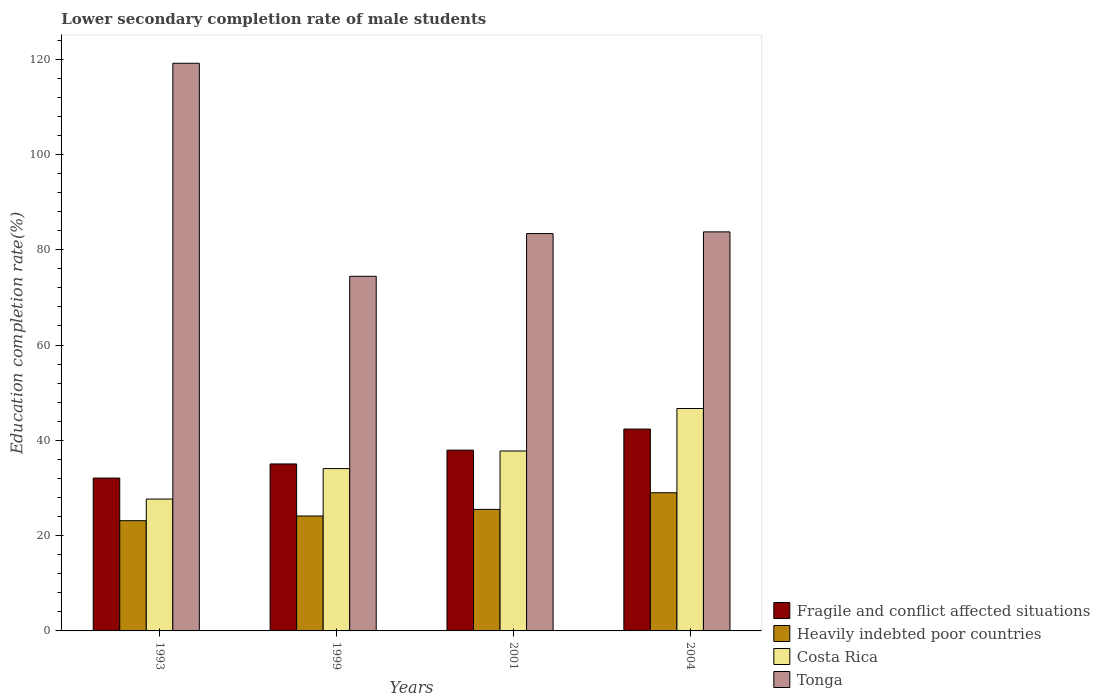How many groups of bars are there?
Provide a succinct answer. 4. Are the number of bars per tick equal to the number of legend labels?
Give a very brief answer. Yes. How many bars are there on the 2nd tick from the left?
Provide a short and direct response. 4. In how many cases, is the number of bars for a given year not equal to the number of legend labels?
Your answer should be compact. 0. What is the lower secondary completion rate of male students in Heavily indebted poor countries in 1993?
Make the answer very short. 23.13. Across all years, what is the maximum lower secondary completion rate of male students in Fragile and conflict affected situations?
Offer a very short reply. 42.36. Across all years, what is the minimum lower secondary completion rate of male students in Fragile and conflict affected situations?
Provide a short and direct response. 32.08. In which year was the lower secondary completion rate of male students in Fragile and conflict affected situations minimum?
Your answer should be very brief. 1993. What is the total lower secondary completion rate of male students in Fragile and conflict affected situations in the graph?
Offer a terse response. 147.43. What is the difference between the lower secondary completion rate of male students in Fragile and conflict affected situations in 1999 and that in 2004?
Make the answer very short. -7.32. What is the difference between the lower secondary completion rate of male students in Tonga in 1999 and the lower secondary completion rate of male students in Fragile and conflict affected situations in 2004?
Offer a very short reply. 32.06. What is the average lower secondary completion rate of male students in Fragile and conflict affected situations per year?
Your answer should be compact. 36.86. In the year 2001, what is the difference between the lower secondary completion rate of male students in Fragile and conflict affected situations and lower secondary completion rate of male students in Heavily indebted poor countries?
Make the answer very short. 12.43. In how many years, is the lower secondary completion rate of male students in Costa Rica greater than 4 %?
Give a very brief answer. 4. What is the ratio of the lower secondary completion rate of male students in Tonga in 1999 to that in 2004?
Ensure brevity in your answer.  0.89. Is the lower secondary completion rate of male students in Tonga in 1993 less than that in 2004?
Offer a terse response. No. Is the difference between the lower secondary completion rate of male students in Fragile and conflict affected situations in 1999 and 2001 greater than the difference between the lower secondary completion rate of male students in Heavily indebted poor countries in 1999 and 2001?
Give a very brief answer. No. What is the difference between the highest and the second highest lower secondary completion rate of male students in Heavily indebted poor countries?
Give a very brief answer. 3.49. What is the difference between the highest and the lowest lower secondary completion rate of male students in Costa Rica?
Keep it short and to the point. 19. Is the sum of the lower secondary completion rate of male students in Tonga in 1999 and 2004 greater than the maximum lower secondary completion rate of male students in Fragile and conflict affected situations across all years?
Give a very brief answer. Yes. What does the 1st bar from the left in 1993 represents?
Ensure brevity in your answer.  Fragile and conflict affected situations. Is it the case that in every year, the sum of the lower secondary completion rate of male students in Tonga and lower secondary completion rate of male students in Costa Rica is greater than the lower secondary completion rate of male students in Fragile and conflict affected situations?
Offer a terse response. Yes. How many bars are there?
Provide a succinct answer. 16. How many years are there in the graph?
Your answer should be compact. 4. Does the graph contain grids?
Offer a very short reply. No. Where does the legend appear in the graph?
Ensure brevity in your answer.  Bottom right. How many legend labels are there?
Make the answer very short. 4. What is the title of the graph?
Your answer should be compact. Lower secondary completion rate of male students. Does "Portugal" appear as one of the legend labels in the graph?
Your answer should be very brief. No. What is the label or title of the Y-axis?
Provide a succinct answer. Education completion rate(%). What is the Education completion rate(%) of Fragile and conflict affected situations in 1993?
Ensure brevity in your answer.  32.08. What is the Education completion rate(%) in Heavily indebted poor countries in 1993?
Provide a short and direct response. 23.13. What is the Education completion rate(%) of Costa Rica in 1993?
Ensure brevity in your answer.  27.67. What is the Education completion rate(%) of Tonga in 1993?
Make the answer very short. 119.14. What is the Education completion rate(%) in Fragile and conflict affected situations in 1999?
Provide a succinct answer. 35.04. What is the Education completion rate(%) of Heavily indebted poor countries in 1999?
Give a very brief answer. 24.12. What is the Education completion rate(%) in Costa Rica in 1999?
Make the answer very short. 34.07. What is the Education completion rate(%) in Tonga in 1999?
Your answer should be compact. 74.42. What is the Education completion rate(%) of Fragile and conflict affected situations in 2001?
Give a very brief answer. 37.94. What is the Education completion rate(%) in Heavily indebted poor countries in 2001?
Give a very brief answer. 25.51. What is the Education completion rate(%) in Costa Rica in 2001?
Make the answer very short. 37.76. What is the Education completion rate(%) of Tonga in 2001?
Ensure brevity in your answer.  83.39. What is the Education completion rate(%) of Fragile and conflict affected situations in 2004?
Your response must be concise. 42.36. What is the Education completion rate(%) in Heavily indebted poor countries in 2004?
Your answer should be very brief. 29. What is the Education completion rate(%) in Costa Rica in 2004?
Provide a succinct answer. 46.68. What is the Education completion rate(%) of Tonga in 2004?
Your answer should be compact. 83.75. Across all years, what is the maximum Education completion rate(%) of Fragile and conflict affected situations?
Give a very brief answer. 42.36. Across all years, what is the maximum Education completion rate(%) in Heavily indebted poor countries?
Offer a terse response. 29. Across all years, what is the maximum Education completion rate(%) of Costa Rica?
Your response must be concise. 46.68. Across all years, what is the maximum Education completion rate(%) of Tonga?
Give a very brief answer. 119.14. Across all years, what is the minimum Education completion rate(%) of Fragile and conflict affected situations?
Your response must be concise. 32.08. Across all years, what is the minimum Education completion rate(%) in Heavily indebted poor countries?
Provide a succinct answer. 23.13. Across all years, what is the minimum Education completion rate(%) of Costa Rica?
Make the answer very short. 27.67. Across all years, what is the minimum Education completion rate(%) of Tonga?
Offer a terse response. 74.42. What is the total Education completion rate(%) in Fragile and conflict affected situations in the graph?
Provide a succinct answer. 147.43. What is the total Education completion rate(%) of Heavily indebted poor countries in the graph?
Offer a terse response. 101.77. What is the total Education completion rate(%) of Costa Rica in the graph?
Provide a short and direct response. 146.18. What is the total Education completion rate(%) in Tonga in the graph?
Your answer should be compact. 360.69. What is the difference between the Education completion rate(%) of Fragile and conflict affected situations in 1993 and that in 1999?
Your answer should be compact. -2.96. What is the difference between the Education completion rate(%) in Heavily indebted poor countries in 1993 and that in 1999?
Your answer should be very brief. -0.99. What is the difference between the Education completion rate(%) of Costa Rica in 1993 and that in 1999?
Give a very brief answer. -6.4. What is the difference between the Education completion rate(%) in Tonga in 1993 and that in 1999?
Keep it short and to the point. 44.71. What is the difference between the Education completion rate(%) in Fragile and conflict affected situations in 1993 and that in 2001?
Ensure brevity in your answer.  -5.86. What is the difference between the Education completion rate(%) in Heavily indebted poor countries in 1993 and that in 2001?
Your response must be concise. -2.38. What is the difference between the Education completion rate(%) of Costa Rica in 1993 and that in 2001?
Make the answer very short. -10.09. What is the difference between the Education completion rate(%) in Tonga in 1993 and that in 2001?
Give a very brief answer. 35.74. What is the difference between the Education completion rate(%) of Fragile and conflict affected situations in 1993 and that in 2004?
Offer a very short reply. -10.28. What is the difference between the Education completion rate(%) in Heavily indebted poor countries in 1993 and that in 2004?
Make the answer very short. -5.87. What is the difference between the Education completion rate(%) of Costa Rica in 1993 and that in 2004?
Ensure brevity in your answer.  -19. What is the difference between the Education completion rate(%) of Tonga in 1993 and that in 2004?
Make the answer very short. 35.39. What is the difference between the Education completion rate(%) of Fragile and conflict affected situations in 1999 and that in 2001?
Give a very brief answer. -2.9. What is the difference between the Education completion rate(%) of Heavily indebted poor countries in 1999 and that in 2001?
Give a very brief answer. -1.39. What is the difference between the Education completion rate(%) in Costa Rica in 1999 and that in 2001?
Offer a terse response. -3.69. What is the difference between the Education completion rate(%) of Tonga in 1999 and that in 2001?
Your answer should be compact. -8.97. What is the difference between the Education completion rate(%) of Fragile and conflict affected situations in 1999 and that in 2004?
Make the answer very short. -7.32. What is the difference between the Education completion rate(%) of Heavily indebted poor countries in 1999 and that in 2004?
Your response must be concise. -4.88. What is the difference between the Education completion rate(%) in Costa Rica in 1999 and that in 2004?
Your answer should be very brief. -12.61. What is the difference between the Education completion rate(%) of Tonga in 1999 and that in 2004?
Keep it short and to the point. -9.32. What is the difference between the Education completion rate(%) of Fragile and conflict affected situations in 2001 and that in 2004?
Your response must be concise. -4.42. What is the difference between the Education completion rate(%) of Heavily indebted poor countries in 2001 and that in 2004?
Give a very brief answer. -3.49. What is the difference between the Education completion rate(%) in Costa Rica in 2001 and that in 2004?
Offer a terse response. -8.91. What is the difference between the Education completion rate(%) of Tonga in 2001 and that in 2004?
Keep it short and to the point. -0.35. What is the difference between the Education completion rate(%) in Fragile and conflict affected situations in 1993 and the Education completion rate(%) in Heavily indebted poor countries in 1999?
Provide a short and direct response. 7.96. What is the difference between the Education completion rate(%) in Fragile and conflict affected situations in 1993 and the Education completion rate(%) in Costa Rica in 1999?
Make the answer very short. -1.99. What is the difference between the Education completion rate(%) in Fragile and conflict affected situations in 1993 and the Education completion rate(%) in Tonga in 1999?
Offer a terse response. -42.34. What is the difference between the Education completion rate(%) in Heavily indebted poor countries in 1993 and the Education completion rate(%) in Costa Rica in 1999?
Your answer should be very brief. -10.94. What is the difference between the Education completion rate(%) in Heavily indebted poor countries in 1993 and the Education completion rate(%) in Tonga in 1999?
Provide a succinct answer. -51.29. What is the difference between the Education completion rate(%) in Costa Rica in 1993 and the Education completion rate(%) in Tonga in 1999?
Your response must be concise. -46.75. What is the difference between the Education completion rate(%) in Fragile and conflict affected situations in 1993 and the Education completion rate(%) in Heavily indebted poor countries in 2001?
Your response must be concise. 6.57. What is the difference between the Education completion rate(%) in Fragile and conflict affected situations in 1993 and the Education completion rate(%) in Costa Rica in 2001?
Offer a very short reply. -5.68. What is the difference between the Education completion rate(%) in Fragile and conflict affected situations in 1993 and the Education completion rate(%) in Tonga in 2001?
Offer a very short reply. -51.31. What is the difference between the Education completion rate(%) of Heavily indebted poor countries in 1993 and the Education completion rate(%) of Costa Rica in 2001?
Provide a short and direct response. -14.63. What is the difference between the Education completion rate(%) of Heavily indebted poor countries in 1993 and the Education completion rate(%) of Tonga in 2001?
Your answer should be very brief. -60.26. What is the difference between the Education completion rate(%) of Costa Rica in 1993 and the Education completion rate(%) of Tonga in 2001?
Keep it short and to the point. -55.72. What is the difference between the Education completion rate(%) in Fragile and conflict affected situations in 1993 and the Education completion rate(%) in Heavily indebted poor countries in 2004?
Give a very brief answer. 3.08. What is the difference between the Education completion rate(%) of Fragile and conflict affected situations in 1993 and the Education completion rate(%) of Costa Rica in 2004?
Your answer should be very brief. -14.6. What is the difference between the Education completion rate(%) in Fragile and conflict affected situations in 1993 and the Education completion rate(%) in Tonga in 2004?
Your response must be concise. -51.67. What is the difference between the Education completion rate(%) of Heavily indebted poor countries in 1993 and the Education completion rate(%) of Costa Rica in 2004?
Ensure brevity in your answer.  -23.54. What is the difference between the Education completion rate(%) in Heavily indebted poor countries in 1993 and the Education completion rate(%) in Tonga in 2004?
Your answer should be very brief. -60.61. What is the difference between the Education completion rate(%) in Costa Rica in 1993 and the Education completion rate(%) in Tonga in 2004?
Offer a very short reply. -56.07. What is the difference between the Education completion rate(%) in Fragile and conflict affected situations in 1999 and the Education completion rate(%) in Heavily indebted poor countries in 2001?
Provide a succinct answer. 9.53. What is the difference between the Education completion rate(%) in Fragile and conflict affected situations in 1999 and the Education completion rate(%) in Costa Rica in 2001?
Give a very brief answer. -2.72. What is the difference between the Education completion rate(%) in Fragile and conflict affected situations in 1999 and the Education completion rate(%) in Tonga in 2001?
Your answer should be very brief. -48.35. What is the difference between the Education completion rate(%) of Heavily indebted poor countries in 1999 and the Education completion rate(%) of Costa Rica in 2001?
Your answer should be very brief. -13.64. What is the difference between the Education completion rate(%) of Heavily indebted poor countries in 1999 and the Education completion rate(%) of Tonga in 2001?
Make the answer very short. -59.27. What is the difference between the Education completion rate(%) of Costa Rica in 1999 and the Education completion rate(%) of Tonga in 2001?
Keep it short and to the point. -49.32. What is the difference between the Education completion rate(%) of Fragile and conflict affected situations in 1999 and the Education completion rate(%) of Heavily indebted poor countries in 2004?
Offer a terse response. 6.04. What is the difference between the Education completion rate(%) of Fragile and conflict affected situations in 1999 and the Education completion rate(%) of Costa Rica in 2004?
Provide a succinct answer. -11.63. What is the difference between the Education completion rate(%) in Fragile and conflict affected situations in 1999 and the Education completion rate(%) in Tonga in 2004?
Give a very brief answer. -48.7. What is the difference between the Education completion rate(%) in Heavily indebted poor countries in 1999 and the Education completion rate(%) in Costa Rica in 2004?
Your response must be concise. -22.56. What is the difference between the Education completion rate(%) in Heavily indebted poor countries in 1999 and the Education completion rate(%) in Tonga in 2004?
Your response must be concise. -59.63. What is the difference between the Education completion rate(%) of Costa Rica in 1999 and the Education completion rate(%) of Tonga in 2004?
Offer a very short reply. -49.68. What is the difference between the Education completion rate(%) in Fragile and conflict affected situations in 2001 and the Education completion rate(%) in Heavily indebted poor countries in 2004?
Ensure brevity in your answer.  8.94. What is the difference between the Education completion rate(%) of Fragile and conflict affected situations in 2001 and the Education completion rate(%) of Costa Rica in 2004?
Provide a succinct answer. -8.74. What is the difference between the Education completion rate(%) of Fragile and conflict affected situations in 2001 and the Education completion rate(%) of Tonga in 2004?
Your answer should be very brief. -45.81. What is the difference between the Education completion rate(%) of Heavily indebted poor countries in 2001 and the Education completion rate(%) of Costa Rica in 2004?
Offer a very short reply. -21.17. What is the difference between the Education completion rate(%) of Heavily indebted poor countries in 2001 and the Education completion rate(%) of Tonga in 2004?
Offer a terse response. -58.24. What is the difference between the Education completion rate(%) in Costa Rica in 2001 and the Education completion rate(%) in Tonga in 2004?
Make the answer very short. -45.98. What is the average Education completion rate(%) in Fragile and conflict affected situations per year?
Your answer should be very brief. 36.86. What is the average Education completion rate(%) in Heavily indebted poor countries per year?
Your answer should be compact. 25.44. What is the average Education completion rate(%) of Costa Rica per year?
Give a very brief answer. 36.55. What is the average Education completion rate(%) of Tonga per year?
Provide a short and direct response. 90.17. In the year 1993, what is the difference between the Education completion rate(%) in Fragile and conflict affected situations and Education completion rate(%) in Heavily indebted poor countries?
Offer a terse response. 8.95. In the year 1993, what is the difference between the Education completion rate(%) of Fragile and conflict affected situations and Education completion rate(%) of Costa Rica?
Offer a terse response. 4.41. In the year 1993, what is the difference between the Education completion rate(%) in Fragile and conflict affected situations and Education completion rate(%) in Tonga?
Ensure brevity in your answer.  -87.06. In the year 1993, what is the difference between the Education completion rate(%) of Heavily indebted poor countries and Education completion rate(%) of Costa Rica?
Ensure brevity in your answer.  -4.54. In the year 1993, what is the difference between the Education completion rate(%) in Heavily indebted poor countries and Education completion rate(%) in Tonga?
Your response must be concise. -96. In the year 1993, what is the difference between the Education completion rate(%) of Costa Rica and Education completion rate(%) of Tonga?
Offer a terse response. -91.46. In the year 1999, what is the difference between the Education completion rate(%) in Fragile and conflict affected situations and Education completion rate(%) in Heavily indebted poor countries?
Your response must be concise. 10.92. In the year 1999, what is the difference between the Education completion rate(%) in Fragile and conflict affected situations and Education completion rate(%) in Tonga?
Your answer should be compact. -39.38. In the year 1999, what is the difference between the Education completion rate(%) of Heavily indebted poor countries and Education completion rate(%) of Costa Rica?
Give a very brief answer. -9.95. In the year 1999, what is the difference between the Education completion rate(%) of Heavily indebted poor countries and Education completion rate(%) of Tonga?
Keep it short and to the point. -50.3. In the year 1999, what is the difference between the Education completion rate(%) of Costa Rica and Education completion rate(%) of Tonga?
Your response must be concise. -40.35. In the year 2001, what is the difference between the Education completion rate(%) of Fragile and conflict affected situations and Education completion rate(%) of Heavily indebted poor countries?
Your answer should be compact. 12.43. In the year 2001, what is the difference between the Education completion rate(%) of Fragile and conflict affected situations and Education completion rate(%) of Costa Rica?
Ensure brevity in your answer.  0.18. In the year 2001, what is the difference between the Education completion rate(%) of Fragile and conflict affected situations and Education completion rate(%) of Tonga?
Ensure brevity in your answer.  -45.45. In the year 2001, what is the difference between the Education completion rate(%) of Heavily indebted poor countries and Education completion rate(%) of Costa Rica?
Provide a succinct answer. -12.25. In the year 2001, what is the difference between the Education completion rate(%) in Heavily indebted poor countries and Education completion rate(%) in Tonga?
Your response must be concise. -57.88. In the year 2001, what is the difference between the Education completion rate(%) of Costa Rica and Education completion rate(%) of Tonga?
Your answer should be very brief. -45.63. In the year 2004, what is the difference between the Education completion rate(%) in Fragile and conflict affected situations and Education completion rate(%) in Heavily indebted poor countries?
Your answer should be very brief. 13.36. In the year 2004, what is the difference between the Education completion rate(%) of Fragile and conflict affected situations and Education completion rate(%) of Costa Rica?
Offer a terse response. -4.31. In the year 2004, what is the difference between the Education completion rate(%) of Fragile and conflict affected situations and Education completion rate(%) of Tonga?
Offer a terse response. -41.38. In the year 2004, what is the difference between the Education completion rate(%) of Heavily indebted poor countries and Education completion rate(%) of Costa Rica?
Keep it short and to the point. -17.67. In the year 2004, what is the difference between the Education completion rate(%) in Heavily indebted poor countries and Education completion rate(%) in Tonga?
Make the answer very short. -54.74. In the year 2004, what is the difference between the Education completion rate(%) of Costa Rica and Education completion rate(%) of Tonga?
Provide a short and direct response. -37.07. What is the ratio of the Education completion rate(%) of Fragile and conflict affected situations in 1993 to that in 1999?
Offer a very short reply. 0.92. What is the ratio of the Education completion rate(%) of Heavily indebted poor countries in 1993 to that in 1999?
Provide a short and direct response. 0.96. What is the ratio of the Education completion rate(%) of Costa Rica in 1993 to that in 1999?
Provide a short and direct response. 0.81. What is the ratio of the Education completion rate(%) of Tonga in 1993 to that in 1999?
Offer a very short reply. 1.6. What is the ratio of the Education completion rate(%) in Fragile and conflict affected situations in 1993 to that in 2001?
Offer a terse response. 0.85. What is the ratio of the Education completion rate(%) of Heavily indebted poor countries in 1993 to that in 2001?
Keep it short and to the point. 0.91. What is the ratio of the Education completion rate(%) in Costa Rica in 1993 to that in 2001?
Keep it short and to the point. 0.73. What is the ratio of the Education completion rate(%) of Tonga in 1993 to that in 2001?
Make the answer very short. 1.43. What is the ratio of the Education completion rate(%) of Fragile and conflict affected situations in 1993 to that in 2004?
Give a very brief answer. 0.76. What is the ratio of the Education completion rate(%) of Heavily indebted poor countries in 1993 to that in 2004?
Your answer should be very brief. 0.8. What is the ratio of the Education completion rate(%) of Costa Rica in 1993 to that in 2004?
Your answer should be compact. 0.59. What is the ratio of the Education completion rate(%) of Tonga in 1993 to that in 2004?
Give a very brief answer. 1.42. What is the ratio of the Education completion rate(%) in Fragile and conflict affected situations in 1999 to that in 2001?
Your response must be concise. 0.92. What is the ratio of the Education completion rate(%) in Heavily indebted poor countries in 1999 to that in 2001?
Your response must be concise. 0.95. What is the ratio of the Education completion rate(%) in Costa Rica in 1999 to that in 2001?
Your answer should be very brief. 0.9. What is the ratio of the Education completion rate(%) of Tonga in 1999 to that in 2001?
Your answer should be compact. 0.89. What is the ratio of the Education completion rate(%) in Fragile and conflict affected situations in 1999 to that in 2004?
Offer a very short reply. 0.83. What is the ratio of the Education completion rate(%) in Heavily indebted poor countries in 1999 to that in 2004?
Give a very brief answer. 0.83. What is the ratio of the Education completion rate(%) of Costa Rica in 1999 to that in 2004?
Ensure brevity in your answer.  0.73. What is the ratio of the Education completion rate(%) of Tonga in 1999 to that in 2004?
Ensure brevity in your answer.  0.89. What is the ratio of the Education completion rate(%) in Fragile and conflict affected situations in 2001 to that in 2004?
Offer a terse response. 0.9. What is the ratio of the Education completion rate(%) in Heavily indebted poor countries in 2001 to that in 2004?
Ensure brevity in your answer.  0.88. What is the ratio of the Education completion rate(%) in Costa Rica in 2001 to that in 2004?
Give a very brief answer. 0.81. What is the difference between the highest and the second highest Education completion rate(%) in Fragile and conflict affected situations?
Your response must be concise. 4.42. What is the difference between the highest and the second highest Education completion rate(%) of Heavily indebted poor countries?
Ensure brevity in your answer.  3.49. What is the difference between the highest and the second highest Education completion rate(%) of Costa Rica?
Provide a succinct answer. 8.91. What is the difference between the highest and the second highest Education completion rate(%) of Tonga?
Provide a short and direct response. 35.39. What is the difference between the highest and the lowest Education completion rate(%) of Fragile and conflict affected situations?
Your response must be concise. 10.28. What is the difference between the highest and the lowest Education completion rate(%) of Heavily indebted poor countries?
Offer a very short reply. 5.87. What is the difference between the highest and the lowest Education completion rate(%) of Costa Rica?
Give a very brief answer. 19. What is the difference between the highest and the lowest Education completion rate(%) in Tonga?
Your answer should be very brief. 44.71. 